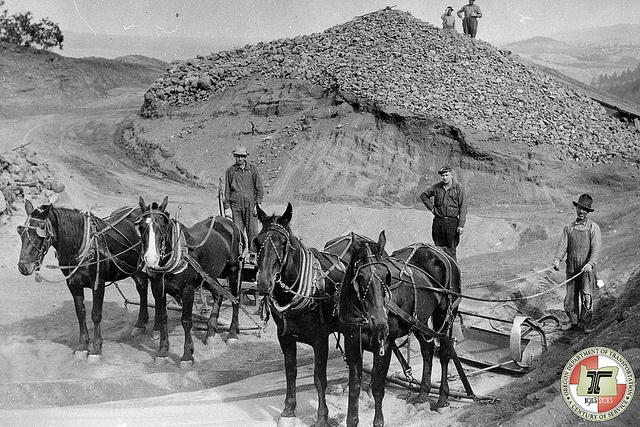Describe the objects in this image and their specific colors. I can see horse in darkgray, black, gray, and lightgray tones, horse in darkgray, black, gray, and lightgray tones, horse in darkgray, black, gray, and lightgray tones, horse in darkgray, black, gray, and lightgray tones, and people in darkgray, gray, black, and lightgray tones in this image. 